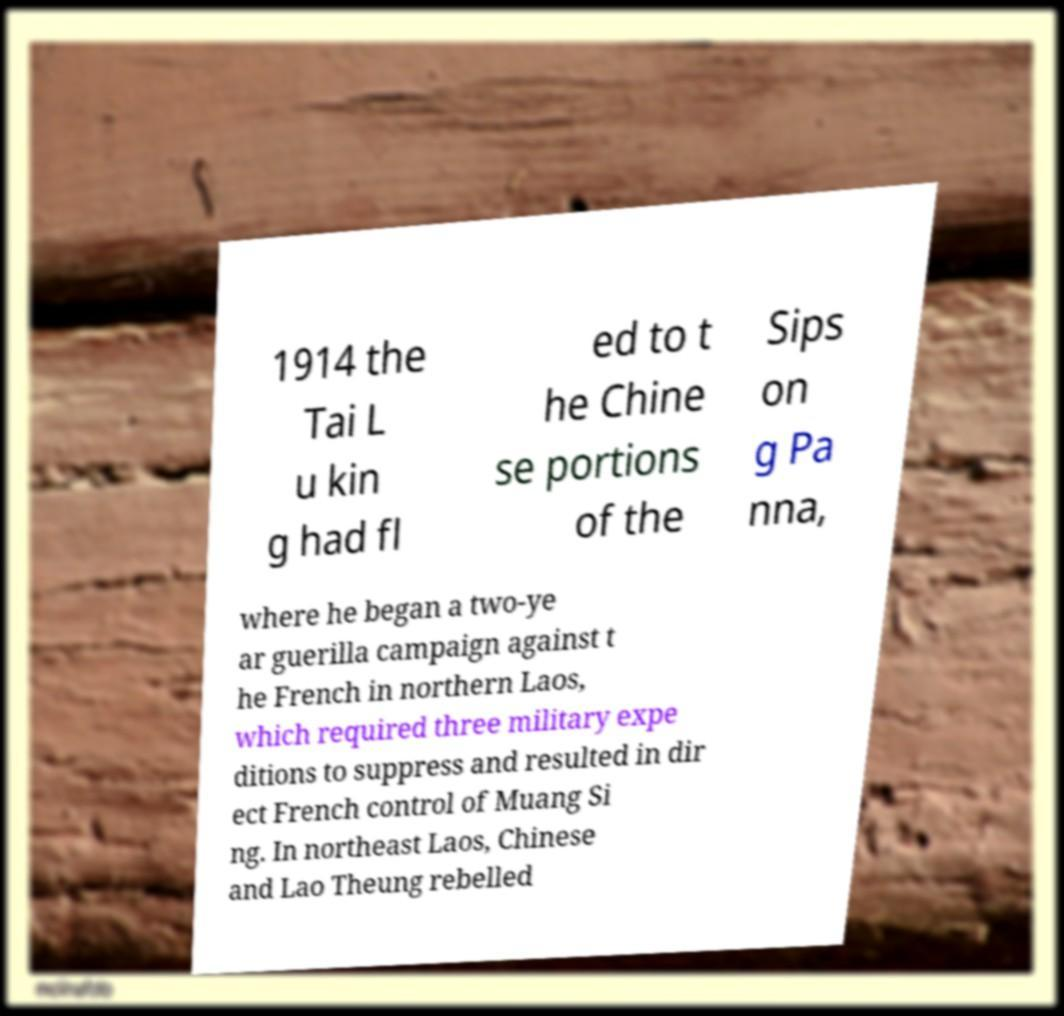Can you accurately transcribe the text from the provided image for me? 1914 the Tai L u kin g had fl ed to t he Chine se portions of the Sips on g Pa nna, where he began a two-ye ar guerilla campaign against t he French in northern Laos, which required three military expe ditions to suppress and resulted in dir ect French control of Muang Si ng. In northeast Laos, Chinese and Lao Theung rebelled 